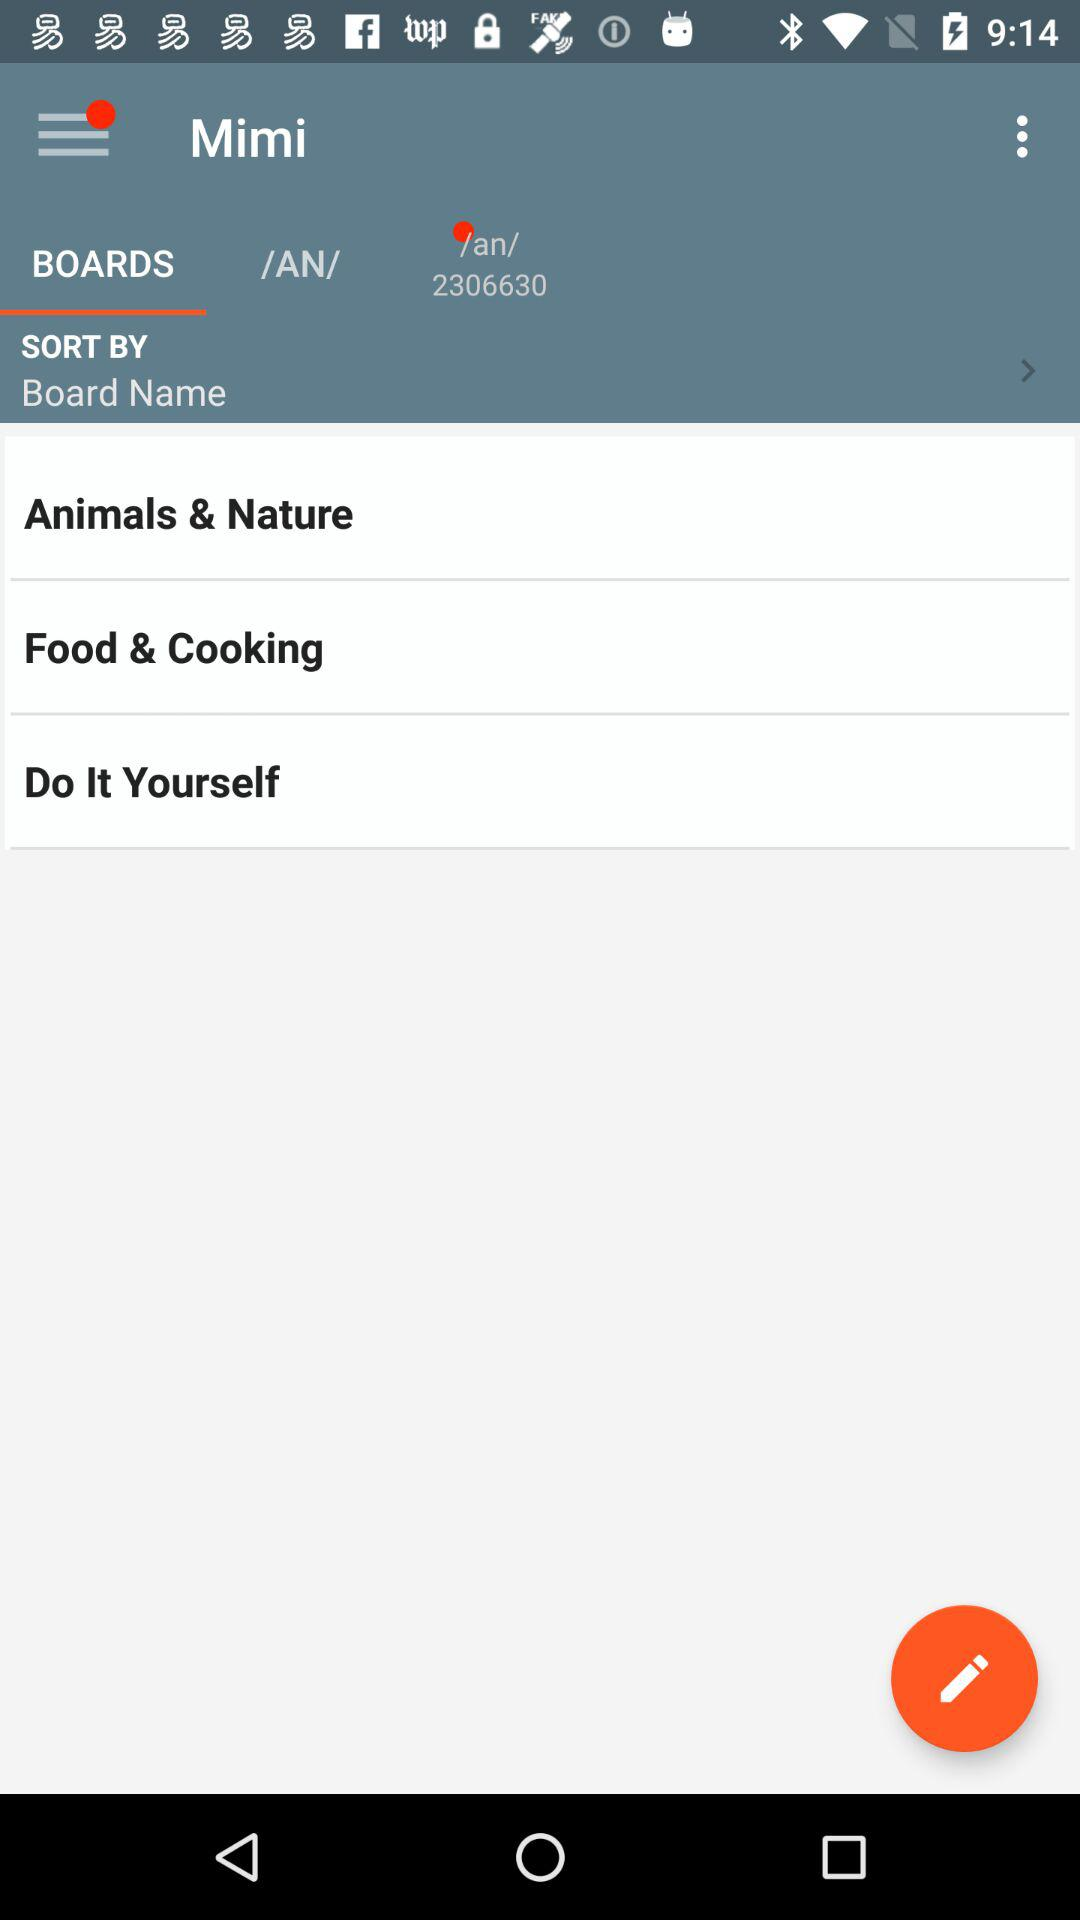What is the option selected for "SORT BY"? The selected option is "Board Name". 